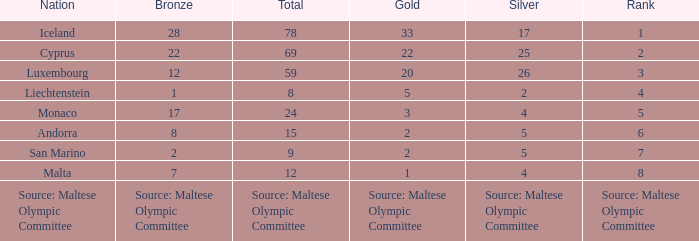What rank is the nation with 2 silver medals? 4.0. 